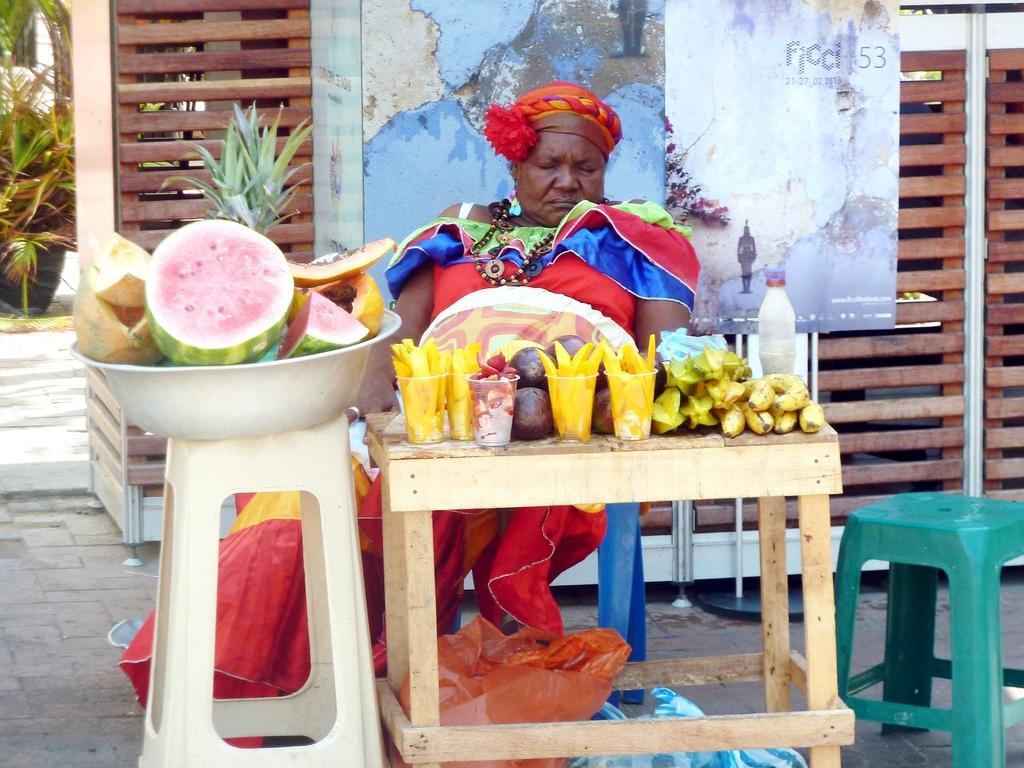Please provide a concise description of this image. There is a person sitting on the chair. This is a table. On the table there are glasses, bottle, and fruits. In the background we can see a poster, plants, and a fence. 